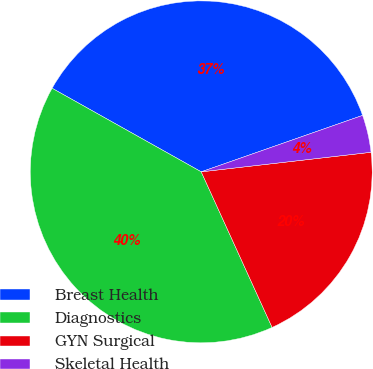Convert chart. <chart><loc_0><loc_0><loc_500><loc_500><pie_chart><fcel>Breast Health<fcel>Diagnostics<fcel>GYN Surgical<fcel>Skeletal Health<nl><fcel>36.51%<fcel>39.93%<fcel>20.02%<fcel>3.53%<nl></chart> 